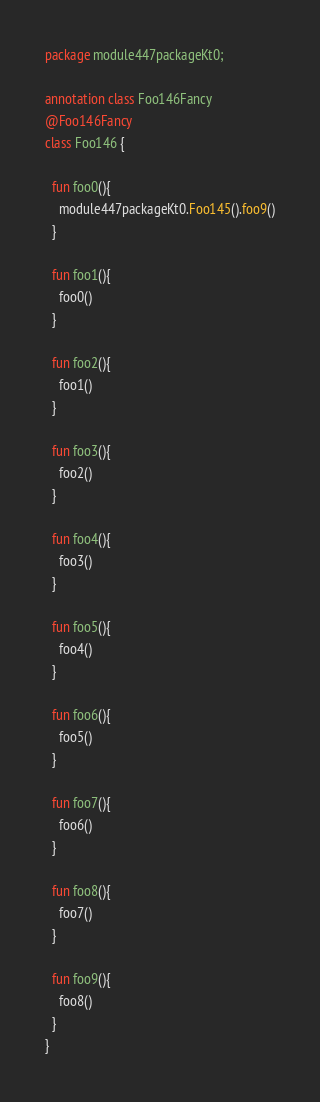Convert code to text. <code><loc_0><loc_0><loc_500><loc_500><_Kotlin_>package module447packageKt0;

annotation class Foo146Fancy
@Foo146Fancy
class Foo146 {

  fun foo0(){
    module447packageKt0.Foo145().foo9()
  }

  fun foo1(){
    foo0()
  }

  fun foo2(){
    foo1()
  }

  fun foo3(){
    foo2()
  }

  fun foo4(){
    foo3()
  }

  fun foo5(){
    foo4()
  }

  fun foo6(){
    foo5()
  }

  fun foo7(){
    foo6()
  }

  fun foo8(){
    foo7()
  }

  fun foo9(){
    foo8()
  }
}</code> 